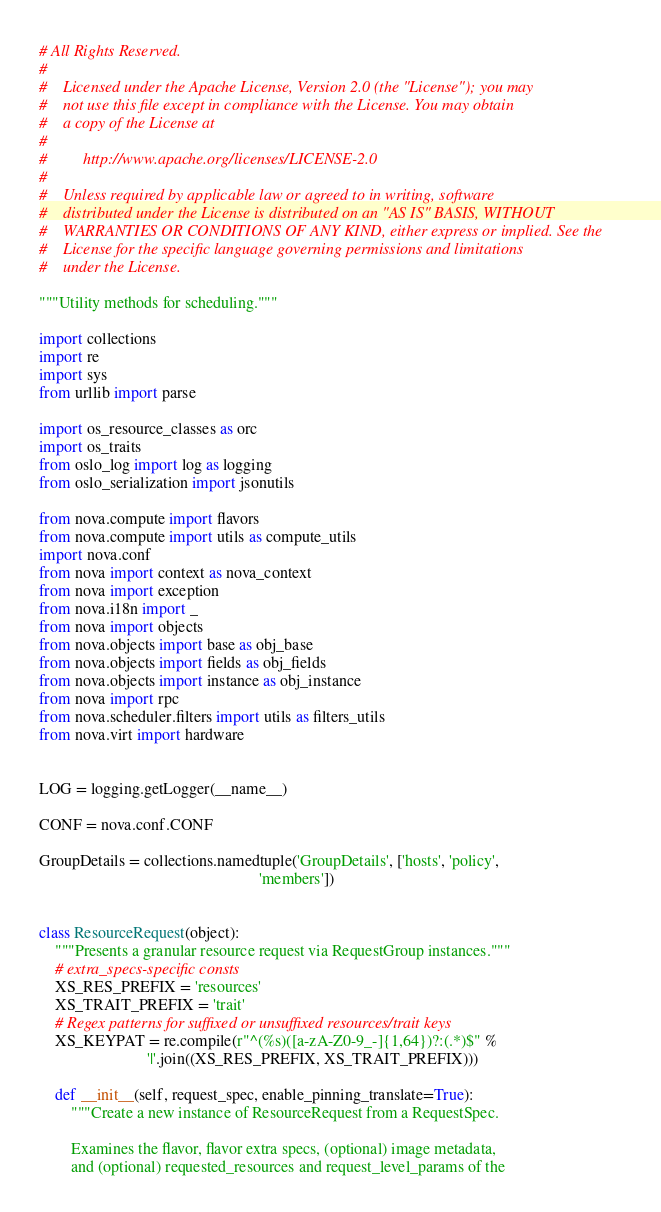Convert code to text. <code><loc_0><loc_0><loc_500><loc_500><_Python_># All Rights Reserved.
#
#    Licensed under the Apache License, Version 2.0 (the "License"); you may
#    not use this file except in compliance with the License. You may obtain
#    a copy of the License at
#
#         http://www.apache.org/licenses/LICENSE-2.0
#
#    Unless required by applicable law or agreed to in writing, software
#    distributed under the License is distributed on an "AS IS" BASIS, WITHOUT
#    WARRANTIES OR CONDITIONS OF ANY KIND, either express or implied. See the
#    License for the specific language governing permissions and limitations
#    under the License.

"""Utility methods for scheduling."""

import collections
import re
import sys
from urllib import parse

import os_resource_classes as orc
import os_traits
from oslo_log import log as logging
from oslo_serialization import jsonutils

from nova.compute import flavors
from nova.compute import utils as compute_utils
import nova.conf
from nova import context as nova_context
from nova import exception
from nova.i18n import _
from nova import objects
from nova.objects import base as obj_base
from nova.objects import fields as obj_fields
from nova.objects import instance as obj_instance
from nova import rpc
from nova.scheduler.filters import utils as filters_utils
from nova.virt import hardware


LOG = logging.getLogger(__name__)

CONF = nova.conf.CONF

GroupDetails = collections.namedtuple('GroupDetails', ['hosts', 'policy',
                                                       'members'])


class ResourceRequest(object):
    """Presents a granular resource request via RequestGroup instances."""
    # extra_specs-specific consts
    XS_RES_PREFIX = 'resources'
    XS_TRAIT_PREFIX = 'trait'
    # Regex patterns for suffixed or unsuffixed resources/trait keys
    XS_KEYPAT = re.compile(r"^(%s)([a-zA-Z0-9_-]{1,64})?:(.*)$" %
                           '|'.join((XS_RES_PREFIX, XS_TRAIT_PREFIX)))

    def __init__(self, request_spec, enable_pinning_translate=True):
        """Create a new instance of ResourceRequest from a RequestSpec.

        Examines the flavor, flavor extra specs, (optional) image metadata,
        and (optional) requested_resources and request_level_params of the</code> 